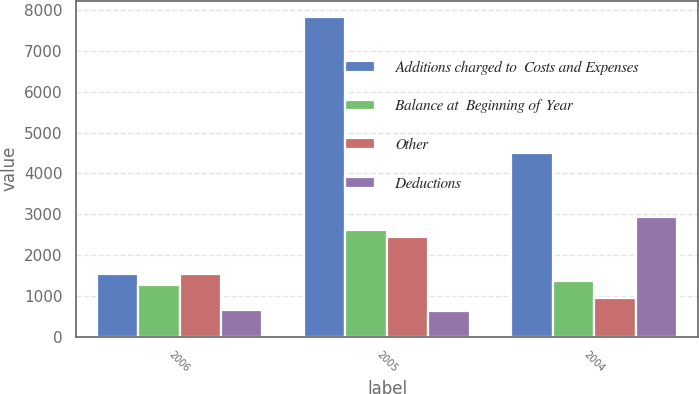Convert chart. <chart><loc_0><loc_0><loc_500><loc_500><stacked_bar_chart><ecel><fcel>2006<fcel>2005<fcel>2004<nl><fcel>Additions charged to  Costs and Expenses<fcel>1539<fcel>7838<fcel>4498<nl><fcel>Balance at  Beginning of Year<fcel>1259<fcel>2605<fcel>1370<nl><fcel>Other<fcel>1539<fcel>2443<fcel>952<nl><fcel>Deductions<fcel>658<fcel>625<fcel>2922<nl></chart> 